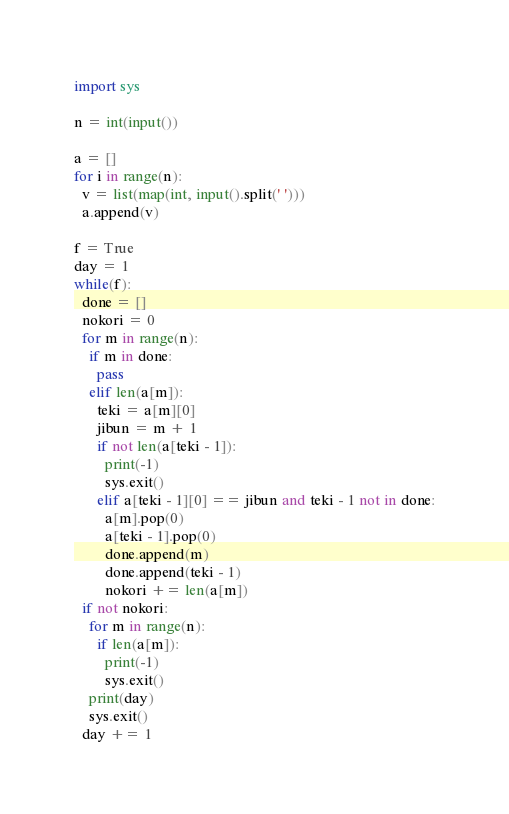Convert code to text. <code><loc_0><loc_0><loc_500><loc_500><_Python_>import sys

n = int(input())

a = []
for i in range(n):
  v = list(map(int, input().split(' ')))
  a.append(v)

f = True
day = 1
while(f):
  done = []
  nokori = 0
  for m in range(n):
    if m in done:
      pass
    elif len(a[m]):
      teki = a[m][0]
      jibun = m + 1
      if not len(a[teki - 1]):
        print(-1)
        sys.exit()
      elif a[teki - 1][0] == jibun and teki - 1 not in done:
        a[m].pop(0)
        a[teki - 1].pop(0)
        done.append(m)
        done.append(teki - 1)
        nokori += len(a[m])
  if not nokori:
    for m in range(n):
      if len(a[m]):
        print(-1)
        sys.exit()
    print(day)
    sys.exit()
  day += 1</code> 